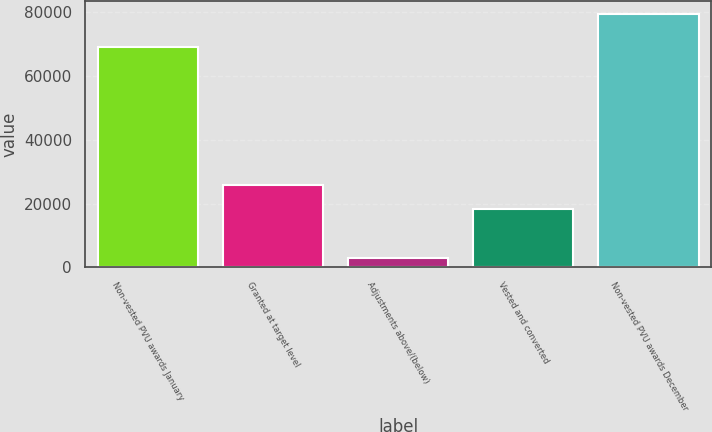Convert chart. <chart><loc_0><loc_0><loc_500><loc_500><bar_chart><fcel>Non-vested PVU awards January<fcel>Granted at target level<fcel>Adjustments above/(below)<fcel>Vested and converted<fcel>Non-vested PVU awards December<nl><fcel>69240<fcel>25967.6<fcel>3000<fcel>18322<fcel>79456<nl></chart> 